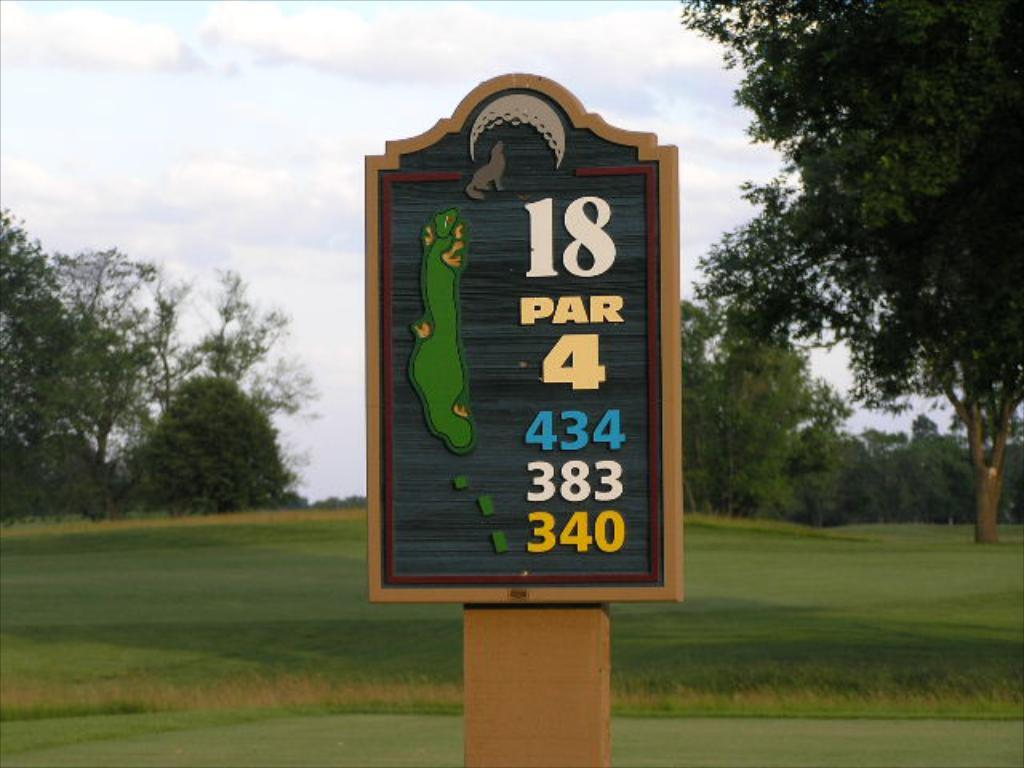Provide a one-sentence caption for the provided image. A sign out in the open field that reads 18 PAR 4 434 383 340 with trees in the background. 